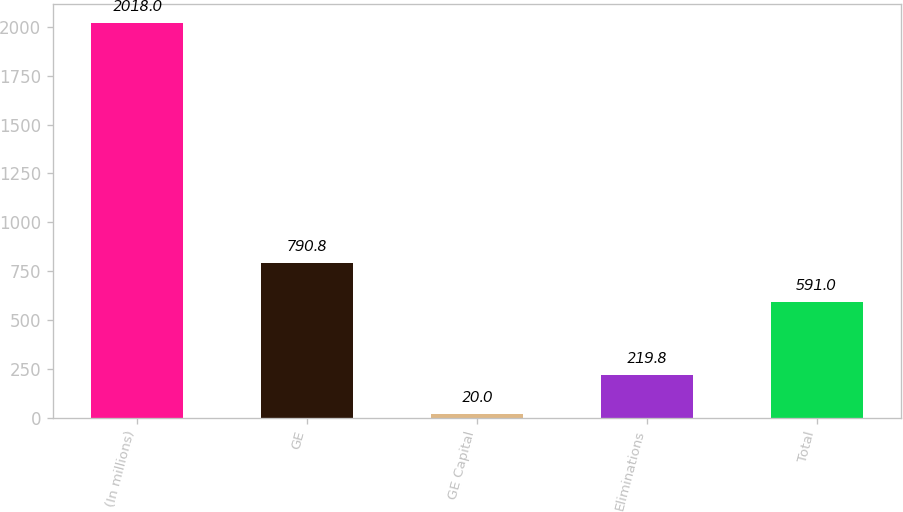<chart> <loc_0><loc_0><loc_500><loc_500><bar_chart><fcel>(In millions)<fcel>GE<fcel>GE Capital<fcel>Eliminations<fcel>Total<nl><fcel>2018<fcel>790.8<fcel>20<fcel>219.8<fcel>591<nl></chart> 